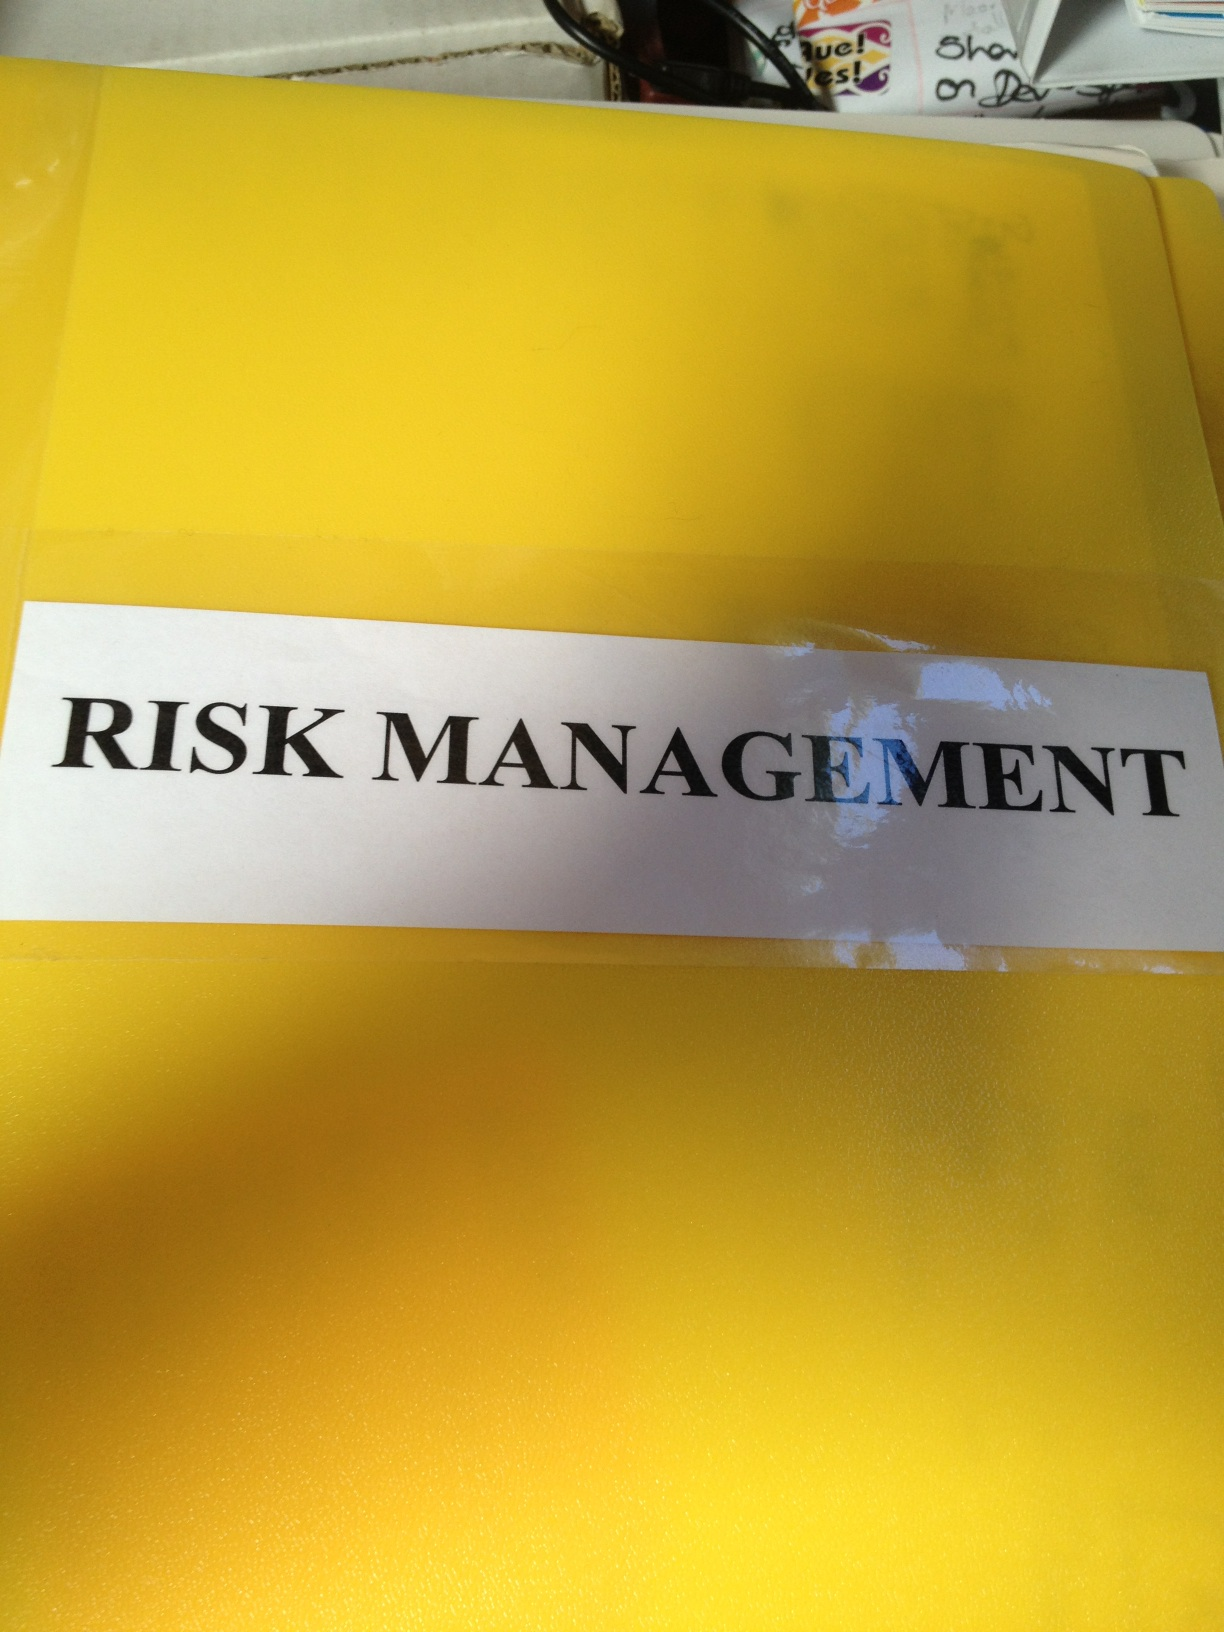What might be the contents of this Risk Management folder? The contents of the Risk Management folder could include documents such as risk assessment reports, risk mitigation plans, business continuity plans, insurance policies, compliance regulations, incident response plans, and various other strategic documents related to identifying and managing potential risks to the organization. Why do you think this folder is yellow? The yellow color of the folder might be chosen for its high visibility and ease of identification. Yellow is a bright and attention-grabbing color, which could help ensure that important documents related to risk management are easily spotted among other files and folders in an office environment. Imagine a scenario where this folder saves the company from a major crisis, In the middle of a critical project, the company suddenly discovers a potential cybersecurity threat that could compromise sensitive data and halt operations. Panic ensues, but the Risk Management folder is quickly retrieved. Inside, the team finds a meticulously outlined incident response plan specifically designed for such threats. The plan details immediate steps to contain the breach, communication protocols with stakeholders, and recovery procedures. Thanks to the preemptive measures documented in the folder, the crisis is efficiently managed, minimizing damage and restoring operations swiftly. The prompt action, guided by the comprehensive risk management strategy, saves the company millions in potential losses and safeguards its reputation. 